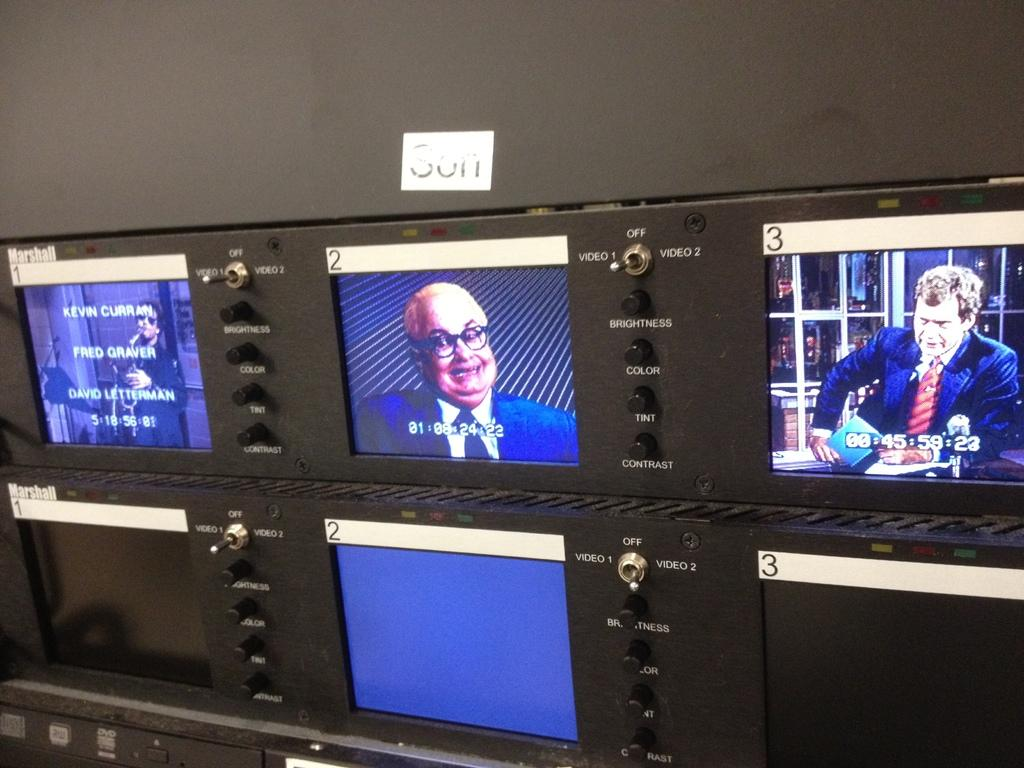<image>
Present a compact description of the photo's key features. A group of tv monitors show various shots of the David Lettermen show. 